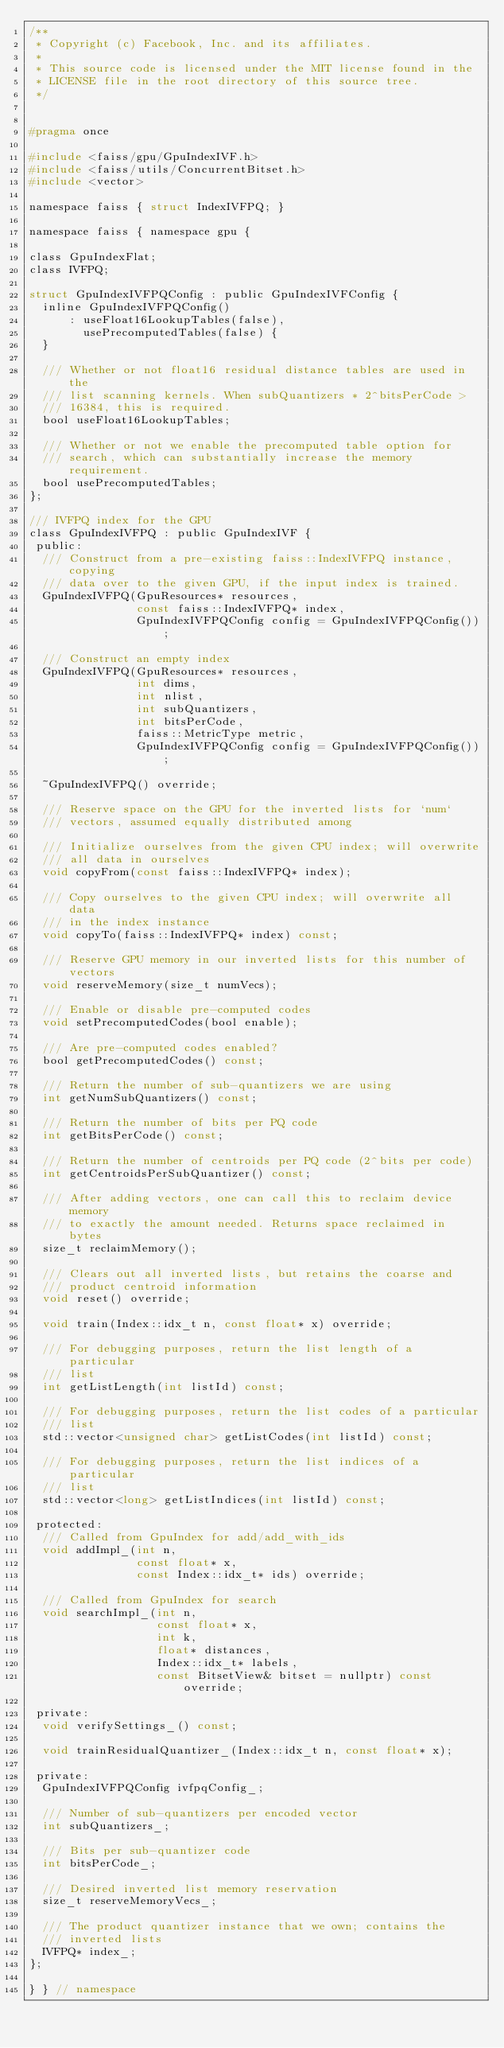Convert code to text. <code><loc_0><loc_0><loc_500><loc_500><_C_>/**
 * Copyright (c) Facebook, Inc. and its affiliates.
 *
 * This source code is licensed under the MIT license found in the
 * LICENSE file in the root directory of this source tree.
 */


#pragma once

#include <faiss/gpu/GpuIndexIVF.h>
#include <faiss/utils/ConcurrentBitset.h>
#include <vector>

namespace faiss { struct IndexIVFPQ; }

namespace faiss { namespace gpu {

class GpuIndexFlat;
class IVFPQ;

struct GpuIndexIVFPQConfig : public GpuIndexIVFConfig {
  inline GpuIndexIVFPQConfig()
      : useFloat16LookupTables(false),
        usePrecomputedTables(false) {
  }

  /// Whether or not float16 residual distance tables are used in the
  /// list scanning kernels. When subQuantizers * 2^bitsPerCode >
  /// 16384, this is required.
  bool useFloat16LookupTables;

  /// Whether or not we enable the precomputed table option for
  /// search, which can substantially increase the memory requirement.
  bool usePrecomputedTables;
};

/// IVFPQ index for the GPU
class GpuIndexIVFPQ : public GpuIndexIVF {
 public:
  /// Construct from a pre-existing faiss::IndexIVFPQ instance, copying
  /// data over to the given GPU, if the input index is trained.
  GpuIndexIVFPQ(GpuResources* resources,
                const faiss::IndexIVFPQ* index,
                GpuIndexIVFPQConfig config = GpuIndexIVFPQConfig());

  /// Construct an empty index
  GpuIndexIVFPQ(GpuResources* resources,
                int dims,
                int nlist,
                int subQuantizers,
                int bitsPerCode,
                faiss::MetricType metric,
                GpuIndexIVFPQConfig config = GpuIndexIVFPQConfig());

  ~GpuIndexIVFPQ() override;

  /// Reserve space on the GPU for the inverted lists for `num`
  /// vectors, assumed equally distributed among

  /// Initialize ourselves from the given CPU index; will overwrite
  /// all data in ourselves
  void copyFrom(const faiss::IndexIVFPQ* index);

  /// Copy ourselves to the given CPU index; will overwrite all data
  /// in the index instance
  void copyTo(faiss::IndexIVFPQ* index) const;

  /// Reserve GPU memory in our inverted lists for this number of vectors
  void reserveMemory(size_t numVecs);

  /// Enable or disable pre-computed codes
  void setPrecomputedCodes(bool enable);

  /// Are pre-computed codes enabled?
  bool getPrecomputedCodes() const;

  /// Return the number of sub-quantizers we are using
  int getNumSubQuantizers() const;

  /// Return the number of bits per PQ code
  int getBitsPerCode() const;

  /// Return the number of centroids per PQ code (2^bits per code)
  int getCentroidsPerSubQuantizer() const;

  /// After adding vectors, one can call this to reclaim device memory
  /// to exactly the amount needed. Returns space reclaimed in bytes
  size_t reclaimMemory();

  /// Clears out all inverted lists, but retains the coarse and
  /// product centroid information
  void reset() override;

  void train(Index::idx_t n, const float* x) override;

  /// For debugging purposes, return the list length of a particular
  /// list
  int getListLength(int listId) const;

  /// For debugging purposes, return the list codes of a particular
  /// list
  std::vector<unsigned char> getListCodes(int listId) const;

  /// For debugging purposes, return the list indices of a particular
  /// list
  std::vector<long> getListIndices(int listId) const;

 protected:
  /// Called from GpuIndex for add/add_with_ids
  void addImpl_(int n,
                const float* x,
                const Index::idx_t* ids) override;

  /// Called from GpuIndex for search
  void searchImpl_(int n,
                   const float* x,
                   int k,
                   float* distances,
                   Index::idx_t* labels,
                   const BitsetView& bitset = nullptr) const override;

 private:
  void verifySettings_() const;

  void trainResidualQuantizer_(Index::idx_t n, const float* x);

 private:
  GpuIndexIVFPQConfig ivfpqConfig_;

  /// Number of sub-quantizers per encoded vector
  int subQuantizers_;

  /// Bits per sub-quantizer code
  int bitsPerCode_;

  /// Desired inverted list memory reservation
  size_t reserveMemoryVecs_;

  /// The product quantizer instance that we own; contains the
  /// inverted lists
  IVFPQ* index_;
};

} } // namespace
</code> 